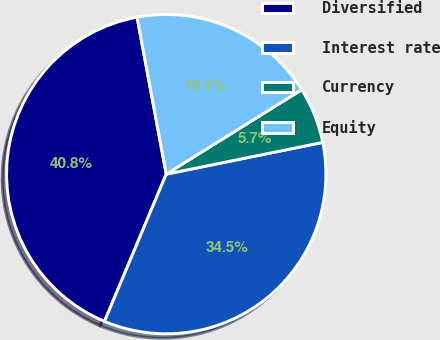<chart> <loc_0><loc_0><loc_500><loc_500><pie_chart><fcel>Diversified<fcel>Interest rate<fcel>Currency<fcel>Equity<nl><fcel>40.75%<fcel>34.5%<fcel>5.69%<fcel>19.05%<nl></chart> 